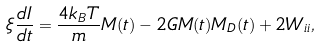<formula> <loc_0><loc_0><loc_500><loc_500>\xi \frac { d I } { d t } = \frac { 4 k _ { B } T } { m } M ( t ) - 2 G M ( t ) M _ { D } ( t ) + 2 W _ { i i } ,</formula> 